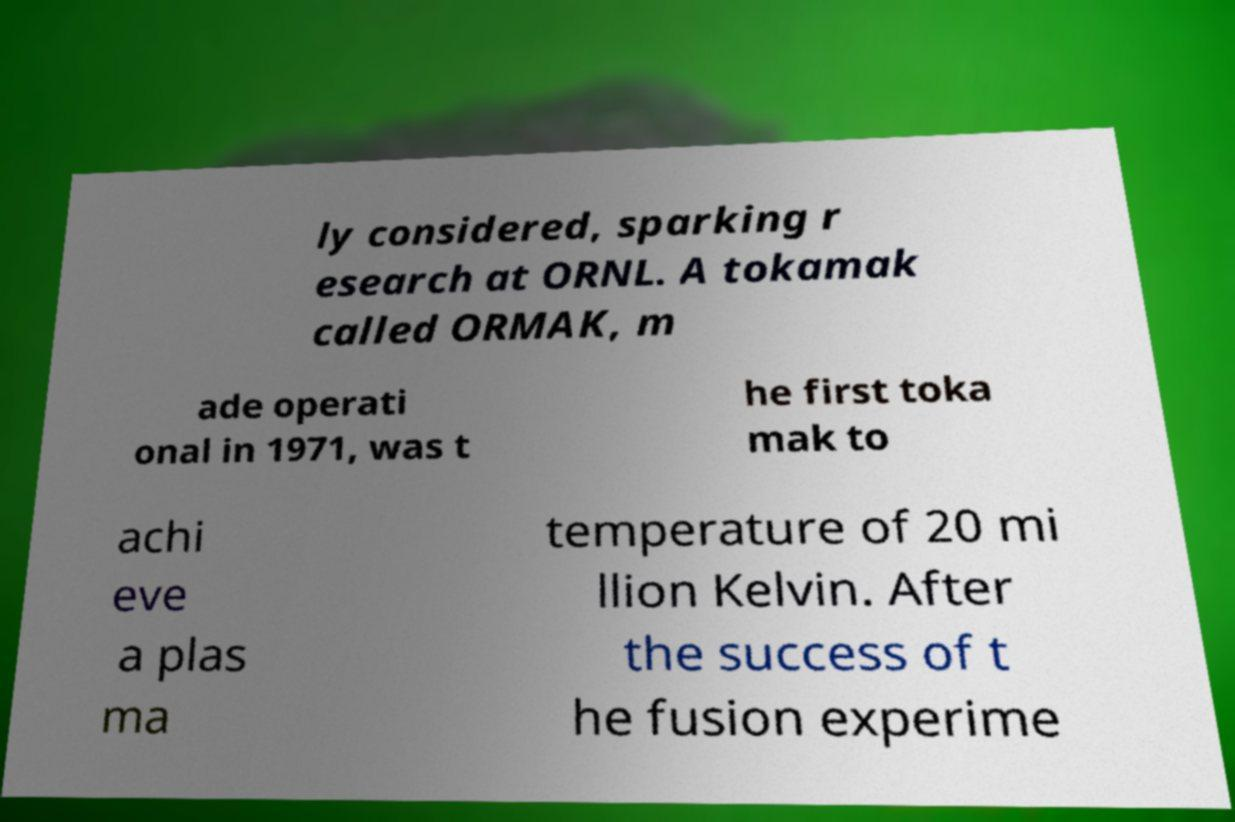Please identify and transcribe the text found in this image. ly considered, sparking r esearch at ORNL. A tokamak called ORMAK, m ade operati onal in 1971, was t he first toka mak to achi eve a plas ma temperature of 20 mi llion Kelvin. After the success of t he fusion experime 